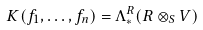Convert formula to latex. <formula><loc_0><loc_0><loc_500><loc_500>K ( f _ { 1 } , \dots , f _ { n } ) = \Lambda _ { * } ^ { R } ( R \otimes _ { S } V )</formula> 